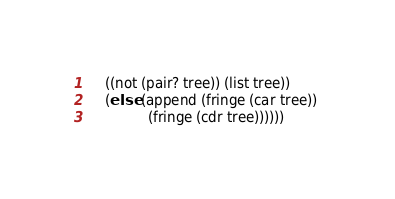Convert code to text. <code><loc_0><loc_0><loc_500><loc_500><_Scheme_>	((not (pair? tree)) (list tree))
	(else (append (fringe (car tree)) 
		      (fringe (cdr tree))))))
</code> 